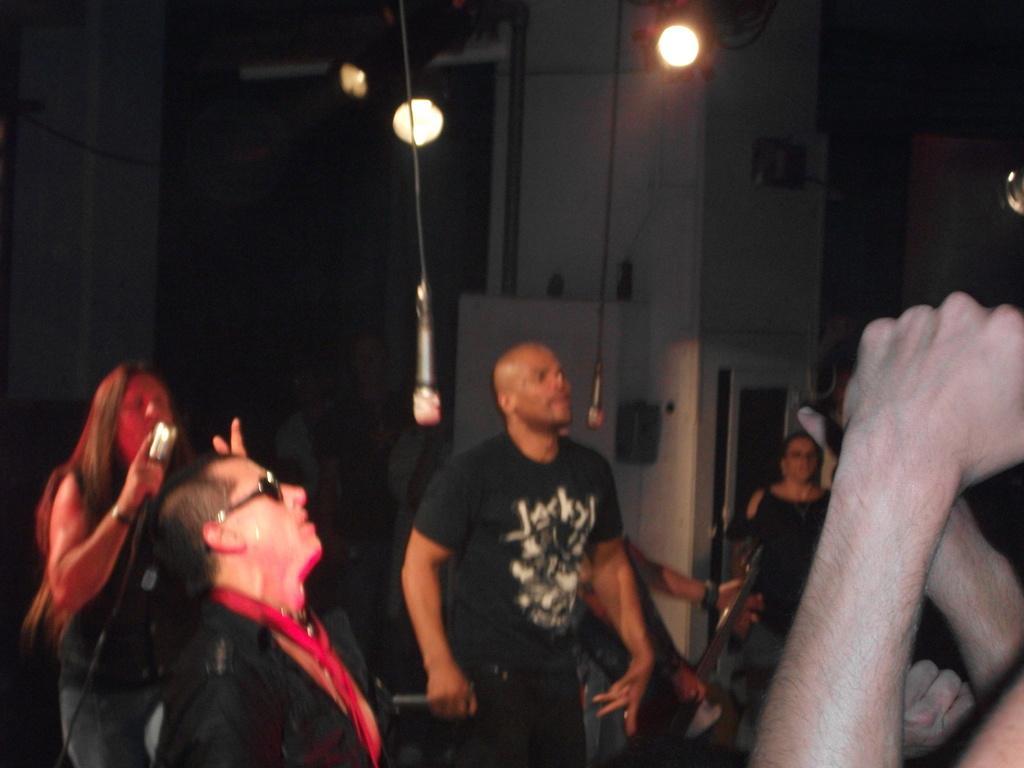Describe this image in one or two sentences. In this picture we can see a group of people, mics, guitar, lights and in the background it is dark. 